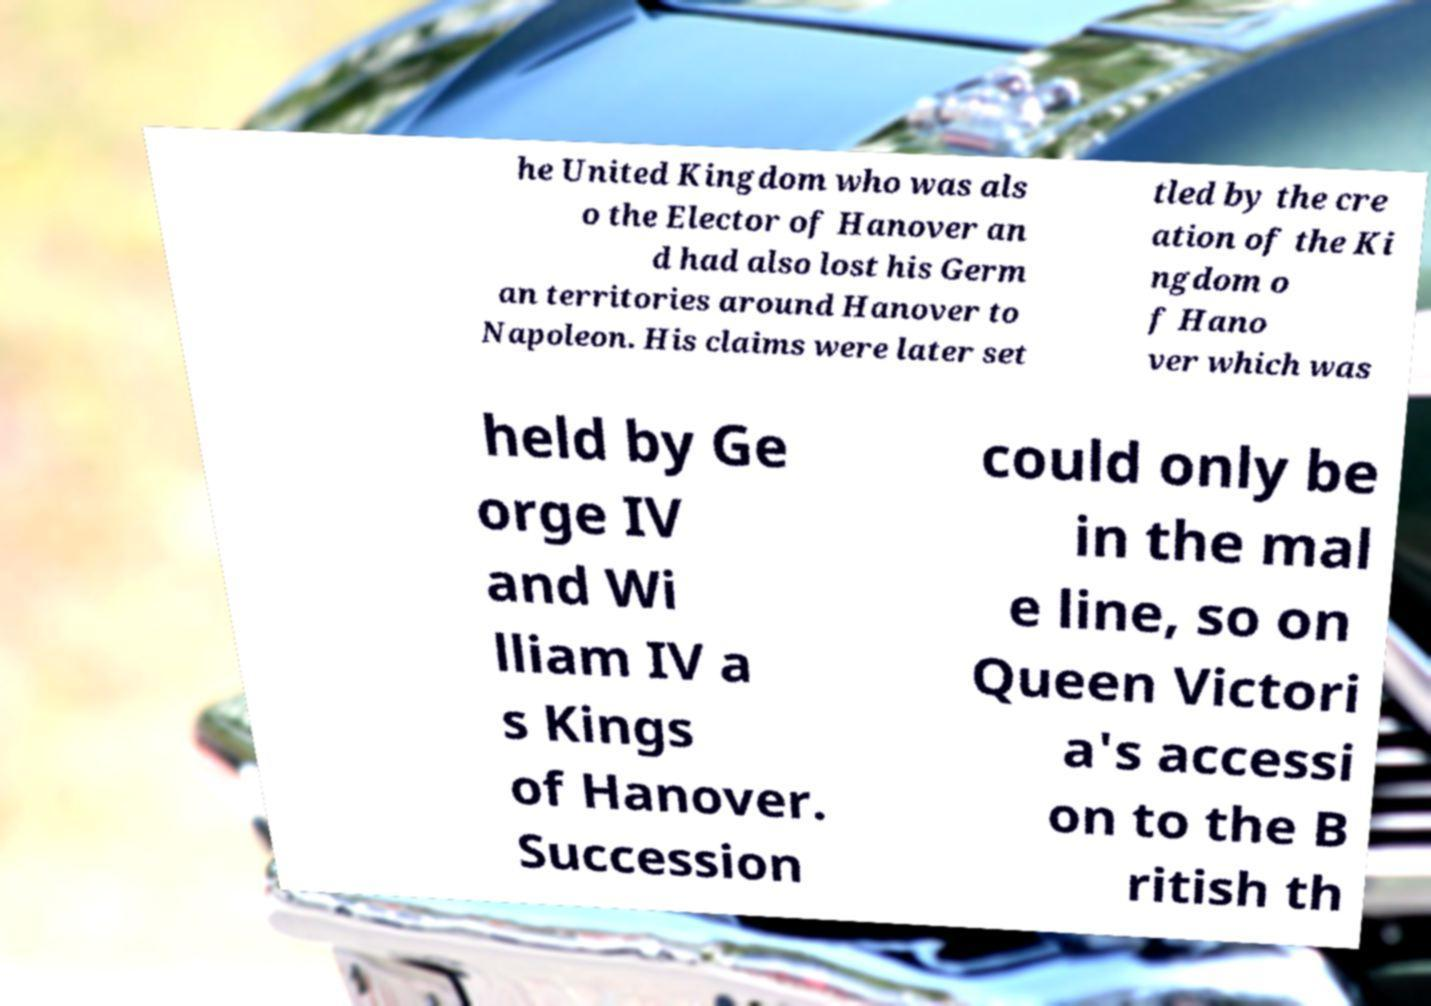Could you extract and type out the text from this image? he United Kingdom who was als o the Elector of Hanover an d had also lost his Germ an territories around Hanover to Napoleon. His claims were later set tled by the cre ation of the Ki ngdom o f Hano ver which was held by Ge orge IV and Wi lliam IV a s Kings of Hanover. Succession could only be in the mal e line, so on Queen Victori a's accessi on to the B ritish th 